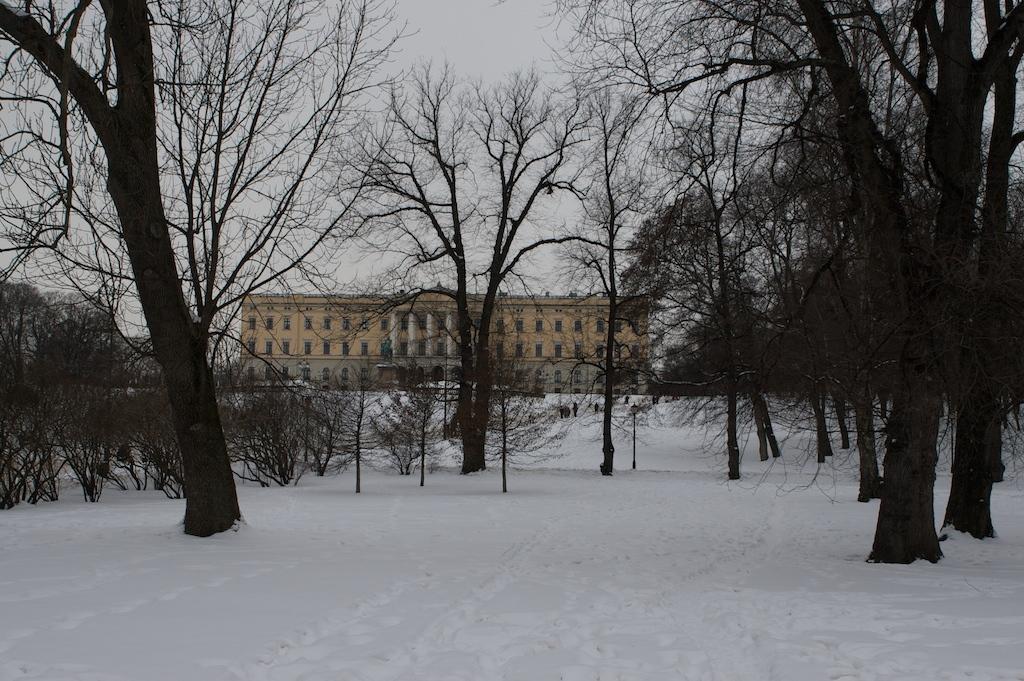Describe this image in one or two sentences. In this picture I can see many trees, plants and snow. In the background I can see the building. At the top I can see the sky and clouds. 